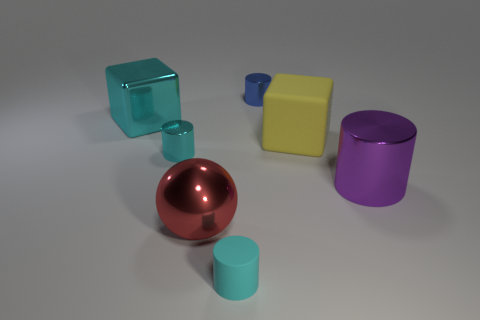How many other things are there of the same color as the big metal block?
Your answer should be very brief. 2. How many blocks are either large rubber objects or small red metallic objects?
Make the answer very short. 1. What color is the rubber thing that is in front of the yellow rubber object behind the red shiny object?
Ensure brevity in your answer.  Cyan. The big purple metallic thing is what shape?
Your answer should be compact. Cylinder. Does the rubber thing behind the purple cylinder have the same size as the red metallic object?
Your answer should be compact. Yes. Is there a small cyan object that has the same material as the cyan block?
Your response must be concise. Yes. What number of objects are either tiny cylinders in front of the large cyan metallic cube or blue shiny cylinders?
Provide a succinct answer. 3. Are any large metallic objects visible?
Offer a very short reply. Yes. What is the shape of the big metallic object that is both in front of the yellow cube and left of the cyan rubber object?
Offer a terse response. Sphere. How big is the cyan cylinder behind the large purple thing?
Provide a succinct answer. Small. 